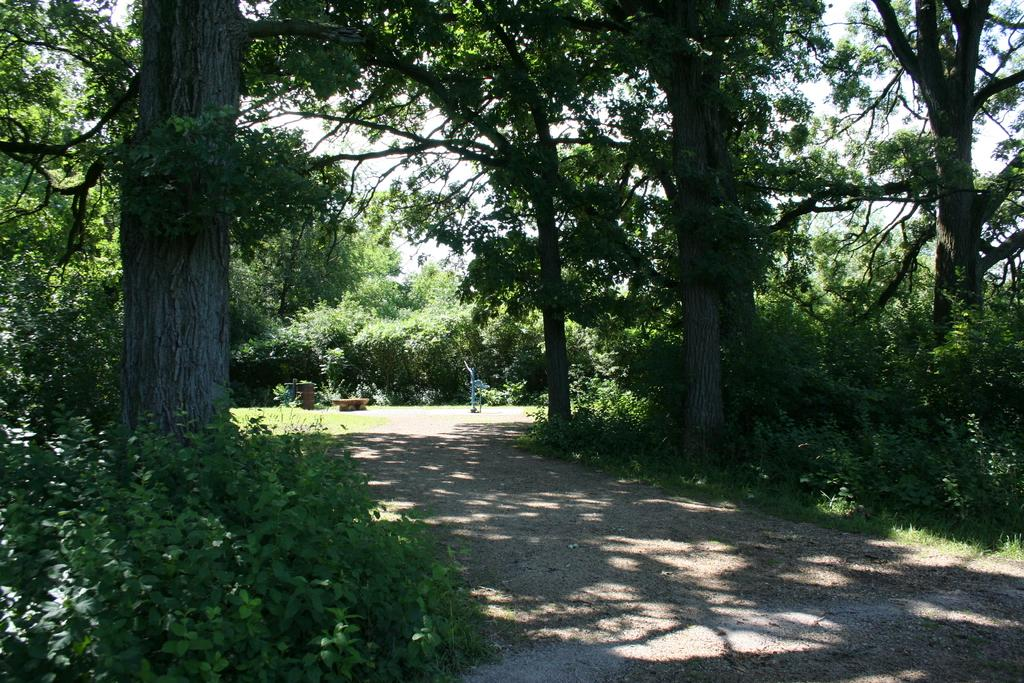What is located at the bottom of the image? There is a small surface ground at the bottom of the image. What can be seen in the background of the image? There are trees in the background of the image. What is visible at the top of the image? The sky is visible at the top of the image. How many girls are wearing stockings in the image? There are no girls or stockings present in the image. What type of cable can be seen connecting the trees in the image? There is no cable connecting the trees in the image; only trees and the sky are visible. 